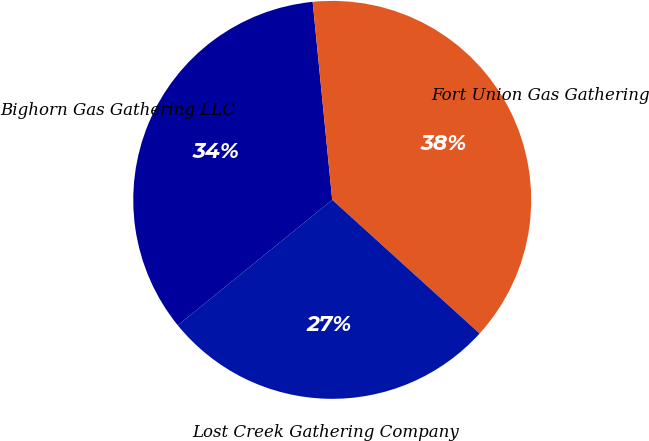<chart> <loc_0><loc_0><loc_500><loc_500><pie_chart><fcel>Bighorn Gas Gathering LLC<fcel>Fort Union Gas Gathering<fcel>Lost Creek Gathering Company<nl><fcel>34.29%<fcel>38.29%<fcel>27.41%<nl></chart> 